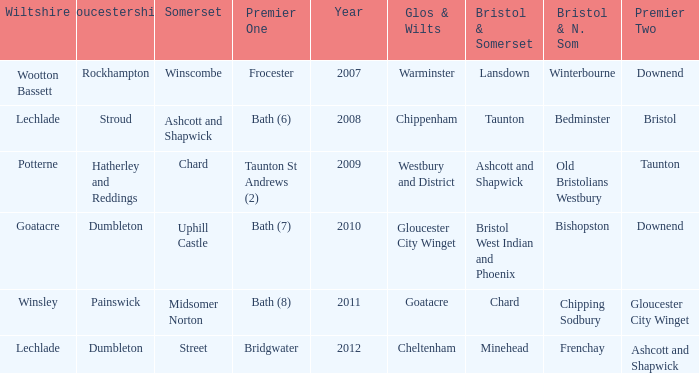What is the somerset for the  year 2009? Chard. 